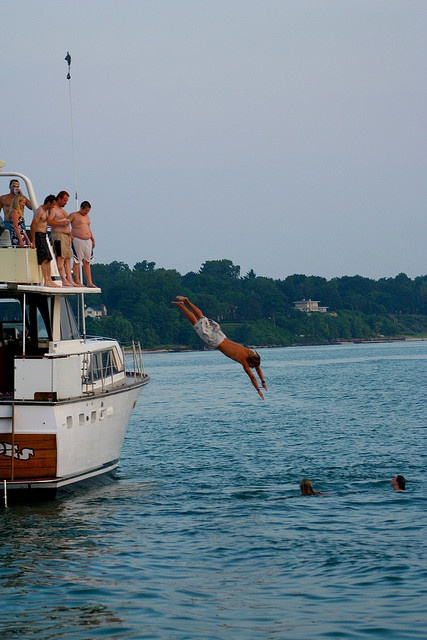Describe the objects in this image and their specific colors. I can see boat in darkgray, black, gray, and maroon tones, people in darkgray, maroon, black, and gray tones, people in darkgray, brown, and maroon tones, people in darkgray, brown, maroon, and black tones, and people in darkgray, black, maroon, and brown tones in this image. 